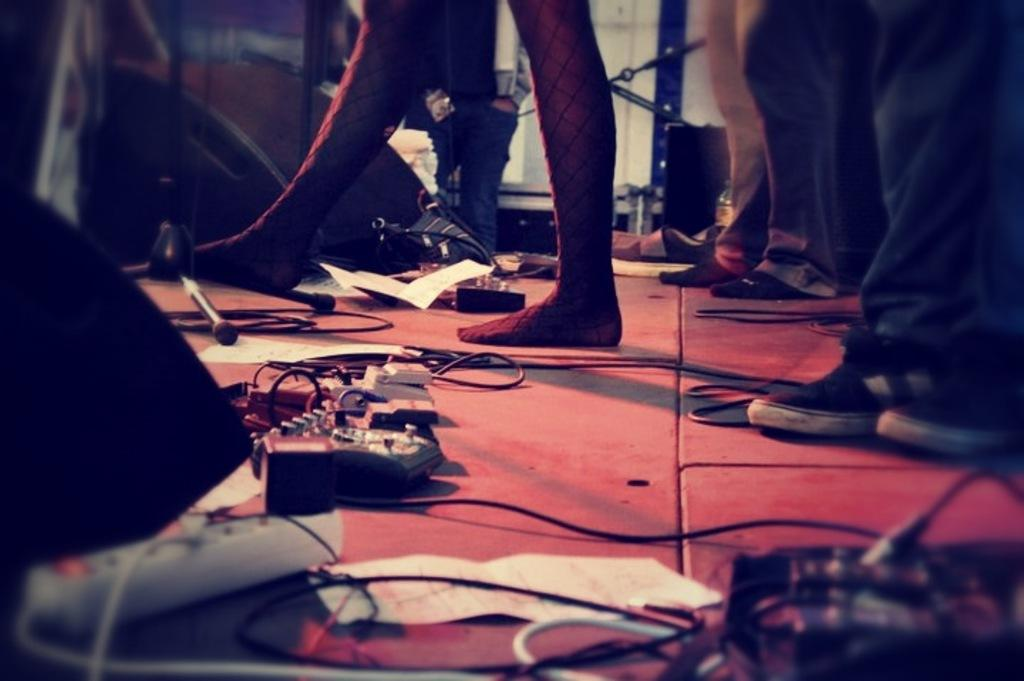What body parts can be seen in the image? There are persons' legs visible in the image. What objects related to work or study can be seen in the image? There are papers and an extension box visible in the image. What items are related to electricity in the image? There are cables and an extension box visible in the image. What objects are related to vision or sight in the image? There are glasses visible in the image. What type of acoustics can be heard in the image? There is no information about sound or acoustics in the image, as it only shows legs, papers, an extension box, cables, and glasses. Are there any visible signs of nerve activity in the image? There is no information about nerve activity in the image, as it only shows legs, papers, an extension box, cables, and glasses. 